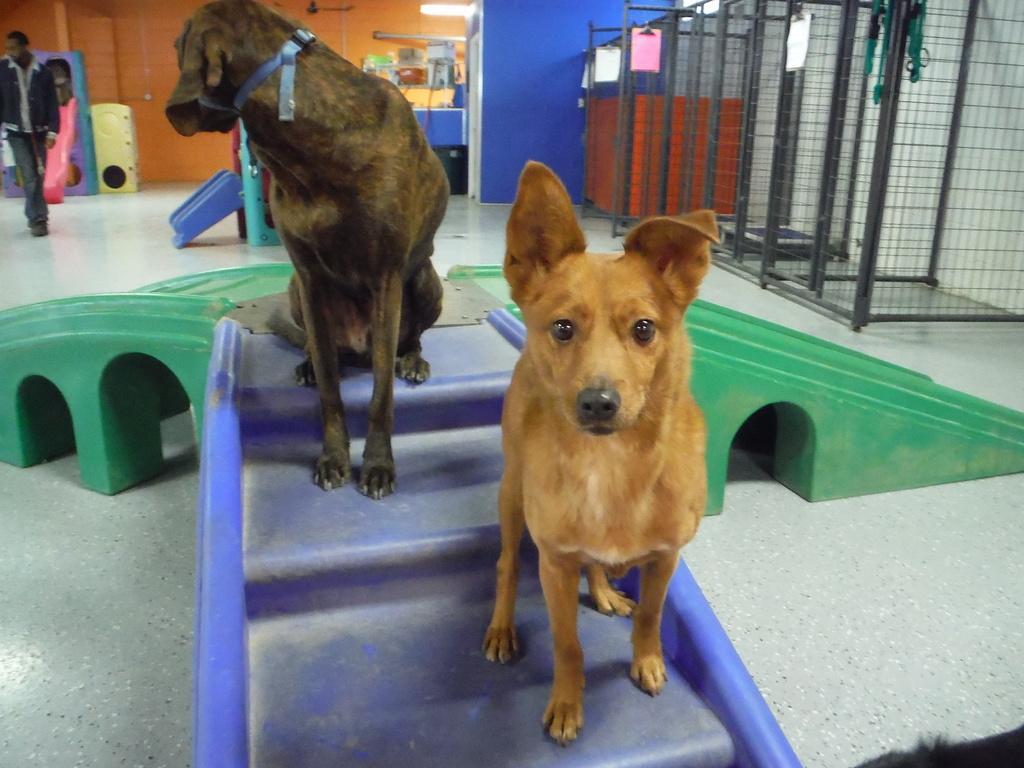Can you describe this image briefly? In this image, I can see two dogs on an object. At the top right side of the image, I can see the cages. In the background, there are few objects and the wall. At the top left side of the image, I can see a person standing on the floor. 